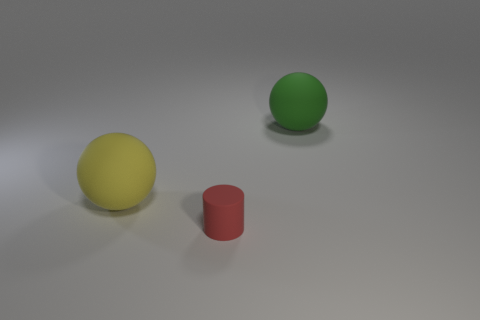Is the number of big yellow balls less than the number of large rubber spheres?
Provide a short and direct response. Yes. Are there any other things that have the same size as the cylinder?
Ensure brevity in your answer.  No. Is the number of big gray things greater than the number of matte things?
Your response must be concise. No. What number of other objects are there of the same color as the small rubber cylinder?
Give a very brief answer. 0. There is a big yellow ball behind the rubber cylinder; how many rubber objects are on the right side of it?
Offer a very short reply. 2. Are there any small red rubber objects behind the green thing?
Your response must be concise. No. What is the shape of the rubber thing that is behind the ball that is in front of the green object?
Ensure brevity in your answer.  Sphere. Are there fewer matte cylinders to the left of the green matte object than big yellow matte things on the right side of the small red object?
Offer a terse response. No. The other thing that is the same shape as the green object is what color?
Ensure brevity in your answer.  Yellow. How many objects are to the left of the big green rubber object and behind the red rubber object?
Provide a succinct answer. 1. 